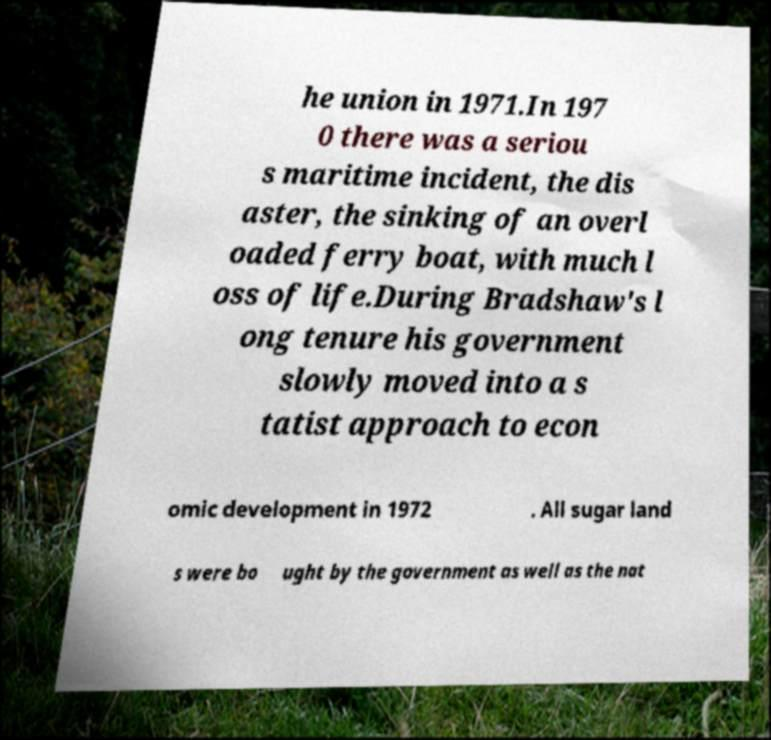Can you read and provide the text displayed in the image?This photo seems to have some interesting text. Can you extract and type it out for me? he union in 1971.In 197 0 there was a seriou s maritime incident, the dis aster, the sinking of an overl oaded ferry boat, with much l oss of life.During Bradshaw's l ong tenure his government slowly moved into a s tatist approach to econ omic development in 1972 . All sugar land s were bo ught by the government as well as the nat 